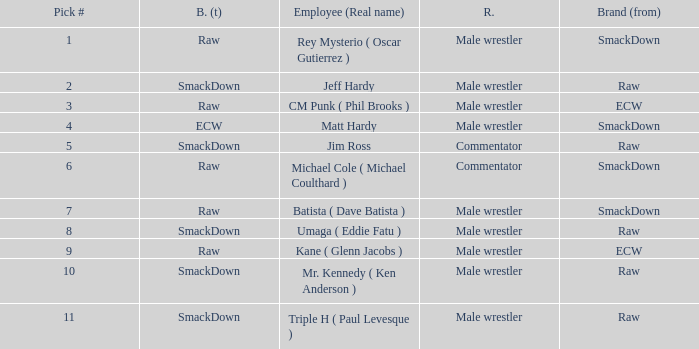What is the real name of the male wrestler from Raw with a pick # smaller than 6? Jeff Hardy. 